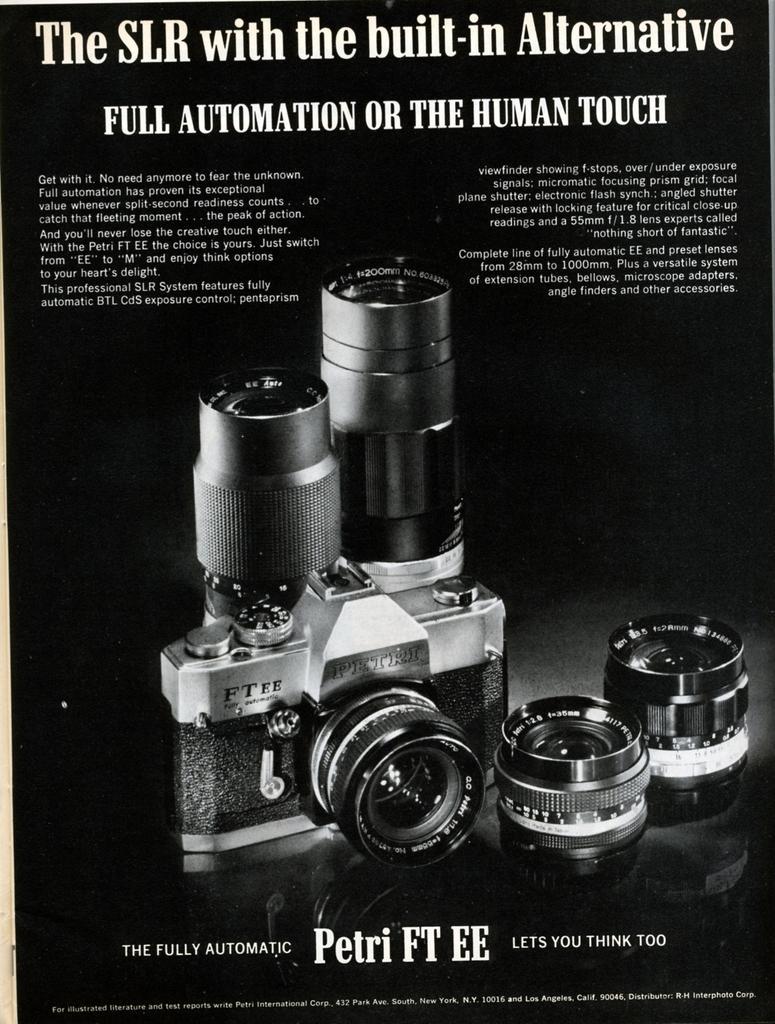How would you summarize this image in a sentence or two? This picture shows a cover photo of a camera with couple of lens and we see text on it. 